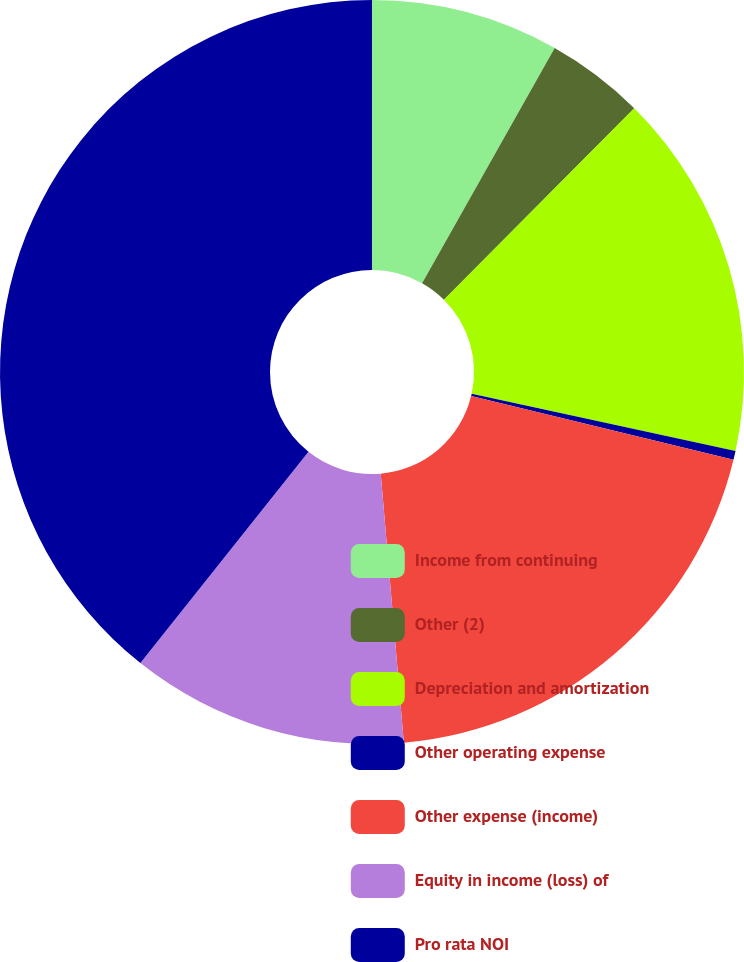<chart> <loc_0><loc_0><loc_500><loc_500><pie_chart><fcel>Income from continuing<fcel>Other (2)<fcel>Depreciation and amortization<fcel>Other operating expense<fcel>Other expense (income)<fcel>Equity in income (loss) of<fcel>Pro rata NOI<nl><fcel>8.17%<fcel>4.28%<fcel>15.95%<fcel>0.39%<fcel>19.84%<fcel>12.06%<fcel>39.3%<nl></chart> 